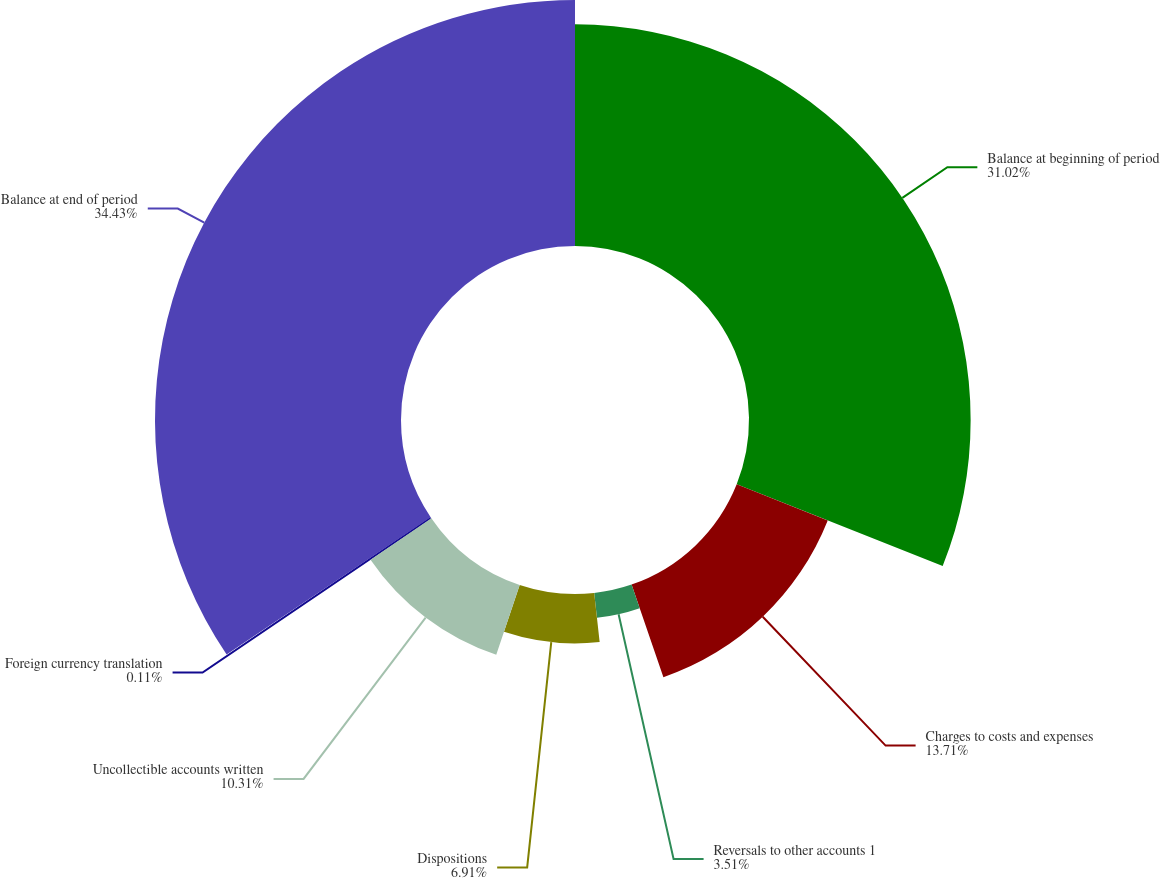Convert chart to OTSL. <chart><loc_0><loc_0><loc_500><loc_500><pie_chart><fcel>Balance at beginning of period<fcel>Charges to costs and expenses<fcel>Reversals to other accounts 1<fcel>Dispositions<fcel>Uncollectible accounts written<fcel>Foreign currency translation<fcel>Balance at end of period<nl><fcel>31.02%<fcel>13.71%<fcel>3.51%<fcel>6.91%<fcel>10.31%<fcel>0.11%<fcel>34.43%<nl></chart> 